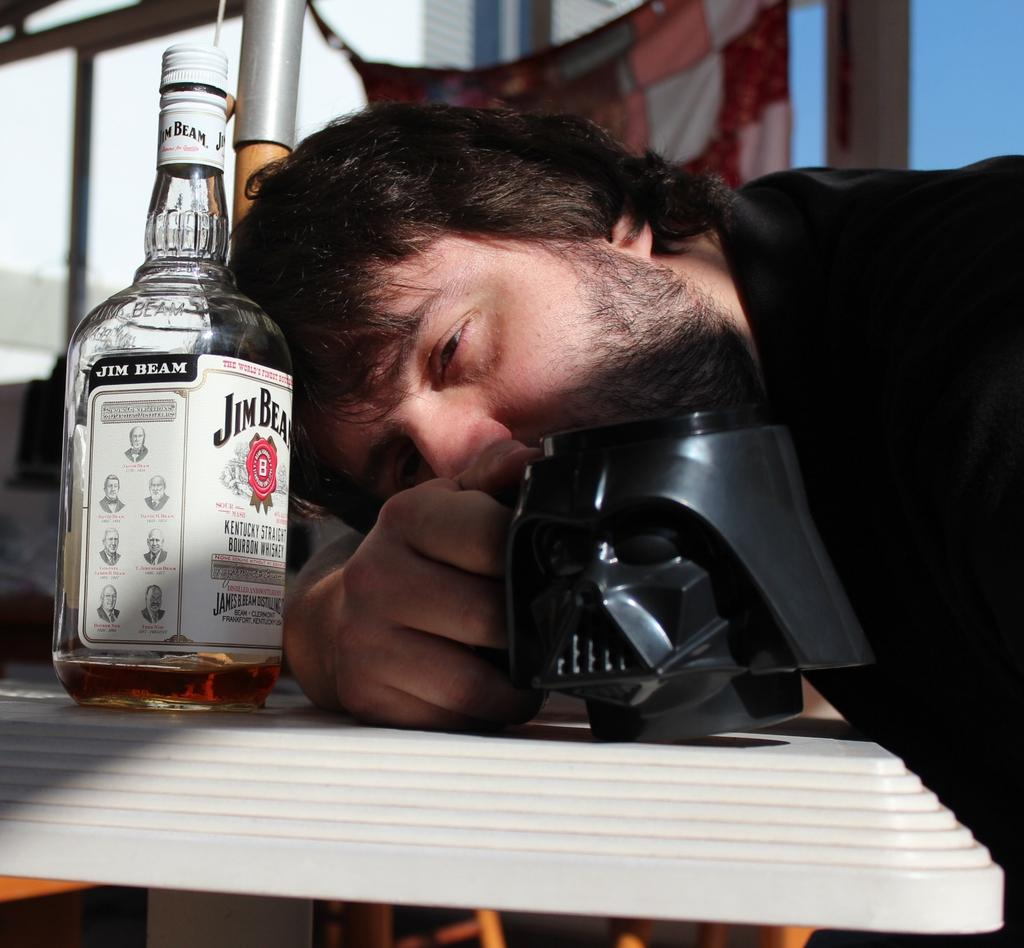Who is present in the image? There is a man in the image. What is the man wearing? The man is wearing a black shirt. What is the man holding in the image? The man is holding a cup. Where is the cup located? The cup is on a table. What is in front of the man? There is a bottle in front of the man. What can be seen in the background of the image? There is a cloth and a stand in the background of the image. How many fingers can be seen on the man's hand in the image? The image does not show the man's fingers, so it is not possible to determine how many fingers are visible. 